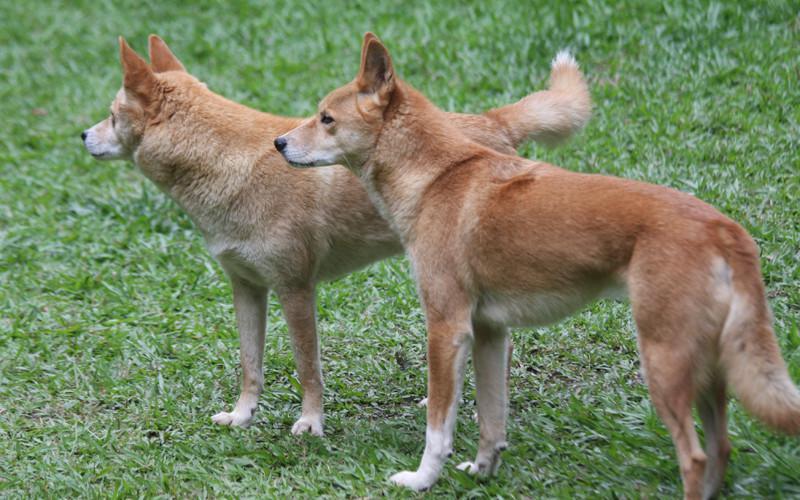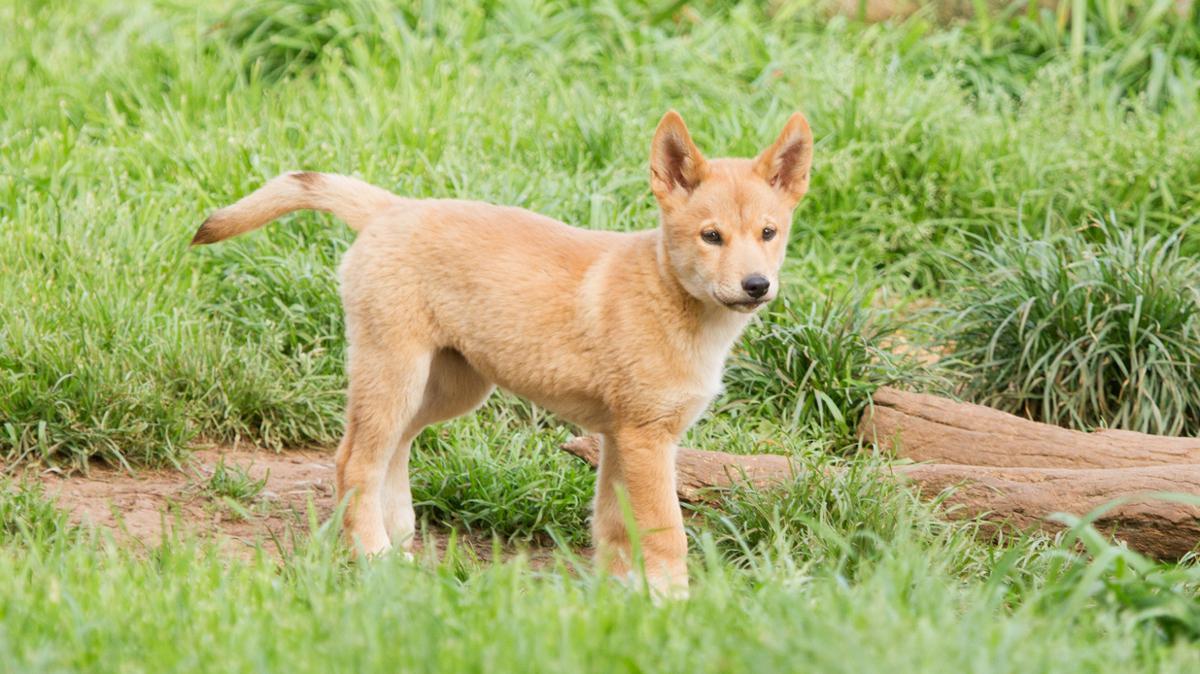The first image is the image on the left, the second image is the image on the right. Evaluate the accuracy of this statement regarding the images: "An image shows at least one dog looking completely to the side.". Is it true? Answer yes or no. Yes. 